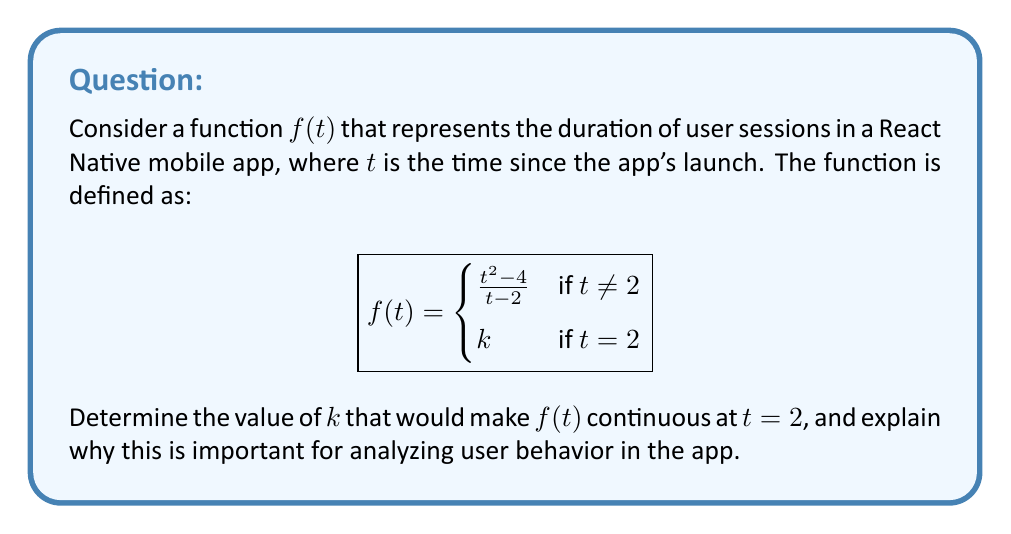Provide a solution to this math problem. To determine the value of $k$ that makes $f(t)$ continuous at $t = 2$, we need to follow these steps:

1) For a function to be continuous at a point, the limit of the function as we approach the point from both sides must exist and be equal to the function's value at that point.

2) Let's first find the limit of $f(t)$ as $t$ approaches 2:

   $$\lim_{t \to 2} f(t) = \lim_{t \to 2} \frac{t^2 - 4}{t - 2}$$

3) This is an indeterminate form (0/0), so we need to factor the numerator:

   $$\lim_{t \to 2} \frac{(t+2)(t-2)}{t - 2}$$

4) The $(t-2)$ cancels out:

   $$\lim_{t \to 2} (t+2) = 4$$

5) For the function to be continuous at $t = 2$, we need:

   $$\lim_{t \to 2} f(t) = f(2)$$

6) Therefore:

   $$4 = k$$

This value of $k$ ensures that there's no "jump" in the function at $t = 2$, which is crucial for accurately analyzing user session durations. In the context of a React Native app, this continuity represents a smooth transition in user behavior around the 2-time unit mark after launch. It allows developers to model and predict user engagement without artificial discontinuities that could skew analytics or lead to incorrect assumptions about user interaction patterns.
Answer: $k = 4$ 